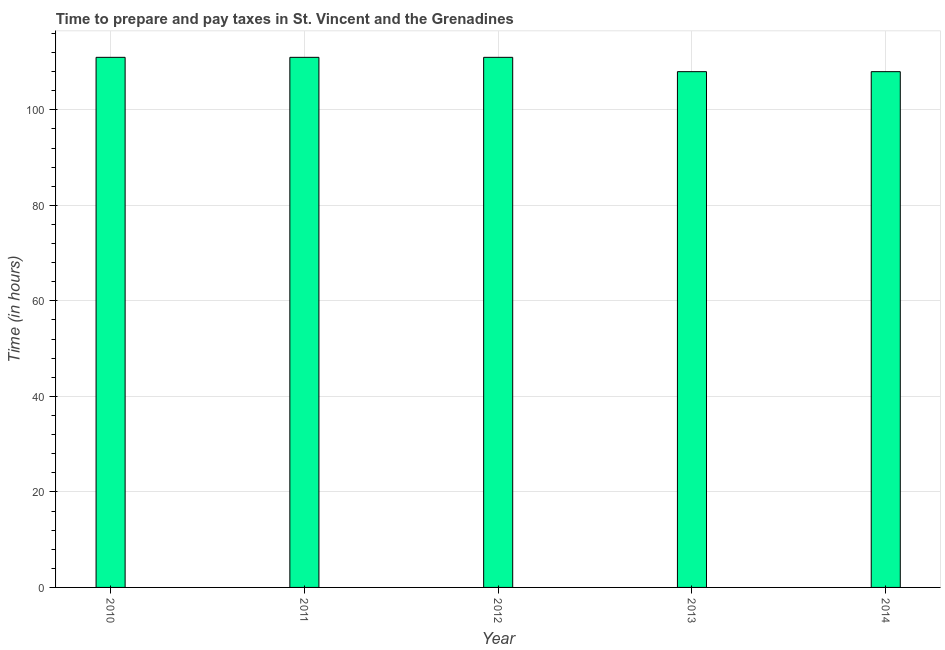Does the graph contain any zero values?
Ensure brevity in your answer.  No. What is the title of the graph?
Your answer should be very brief. Time to prepare and pay taxes in St. Vincent and the Grenadines. What is the label or title of the Y-axis?
Your answer should be very brief. Time (in hours). What is the time to prepare and pay taxes in 2010?
Keep it short and to the point. 111. Across all years, what is the maximum time to prepare and pay taxes?
Offer a terse response. 111. Across all years, what is the minimum time to prepare and pay taxes?
Provide a short and direct response. 108. What is the sum of the time to prepare and pay taxes?
Offer a terse response. 549. What is the difference between the time to prepare and pay taxes in 2011 and 2014?
Give a very brief answer. 3. What is the average time to prepare and pay taxes per year?
Give a very brief answer. 109.8. What is the median time to prepare and pay taxes?
Provide a succinct answer. 111. In how many years, is the time to prepare and pay taxes greater than 68 hours?
Make the answer very short. 5. Do a majority of the years between 2014 and 2011 (inclusive) have time to prepare and pay taxes greater than 36 hours?
Provide a short and direct response. Yes. Is the time to prepare and pay taxes in 2010 less than that in 2013?
Offer a very short reply. No. Is the difference between the time to prepare and pay taxes in 2012 and 2013 greater than the difference between any two years?
Keep it short and to the point. Yes. What is the difference between the highest and the second highest time to prepare and pay taxes?
Your response must be concise. 0. What is the difference between the highest and the lowest time to prepare and pay taxes?
Ensure brevity in your answer.  3. What is the difference between two consecutive major ticks on the Y-axis?
Provide a short and direct response. 20. Are the values on the major ticks of Y-axis written in scientific E-notation?
Ensure brevity in your answer.  No. What is the Time (in hours) of 2010?
Make the answer very short. 111. What is the Time (in hours) in 2011?
Your answer should be compact. 111. What is the Time (in hours) in 2012?
Make the answer very short. 111. What is the Time (in hours) in 2013?
Your response must be concise. 108. What is the Time (in hours) in 2014?
Make the answer very short. 108. What is the difference between the Time (in hours) in 2010 and 2011?
Make the answer very short. 0. What is the difference between the Time (in hours) in 2010 and 2012?
Your response must be concise. 0. What is the difference between the Time (in hours) in 2010 and 2013?
Ensure brevity in your answer.  3. What is the difference between the Time (in hours) in 2010 and 2014?
Provide a short and direct response. 3. What is the difference between the Time (in hours) in 2011 and 2012?
Offer a terse response. 0. What is the difference between the Time (in hours) in 2012 and 2013?
Offer a terse response. 3. What is the difference between the Time (in hours) in 2012 and 2014?
Your response must be concise. 3. What is the ratio of the Time (in hours) in 2010 to that in 2013?
Your answer should be compact. 1.03. What is the ratio of the Time (in hours) in 2010 to that in 2014?
Your answer should be compact. 1.03. What is the ratio of the Time (in hours) in 2011 to that in 2013?
Give a very brief answer. 1.03. What is the ratio of the Time (in hours) in 2011 to that in 2014?
Ensure brevity in your answer.  1.03. What is the ratio of the Time (in hours) in 2012 to that in 2013?
Give a very brief answer. 1.03. What is the ratio of the Time (in hours) in 2012 to that in 2014?
Keep it short and to the point. 1.03. What is the ratio of the Time (in hours) in 2013 to that in 2014?
Provide a short and direct response. 1. 